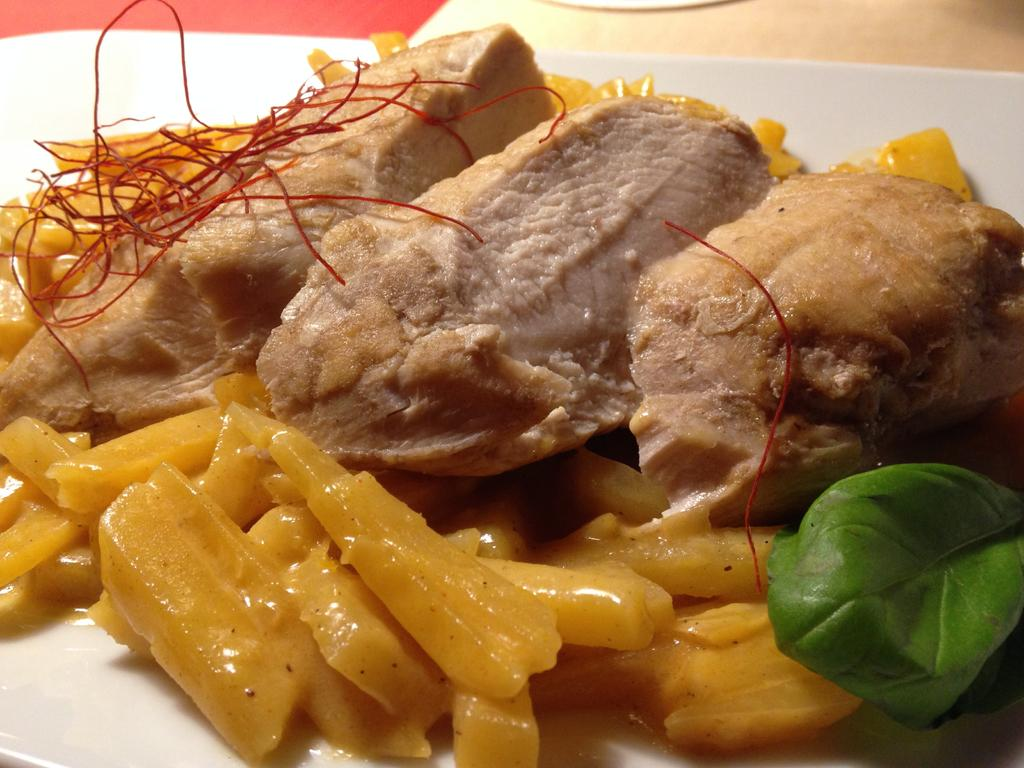What is on the plate that is visible in the image? There is a plate with food in the image. Where is the plate located in the image? The plate is in the center of the image. On what surface is the plate placed? The plate is placed on a table. What type of polish is being applied to the table in the image? There is no polish or any indication of polishing activity in the image. 